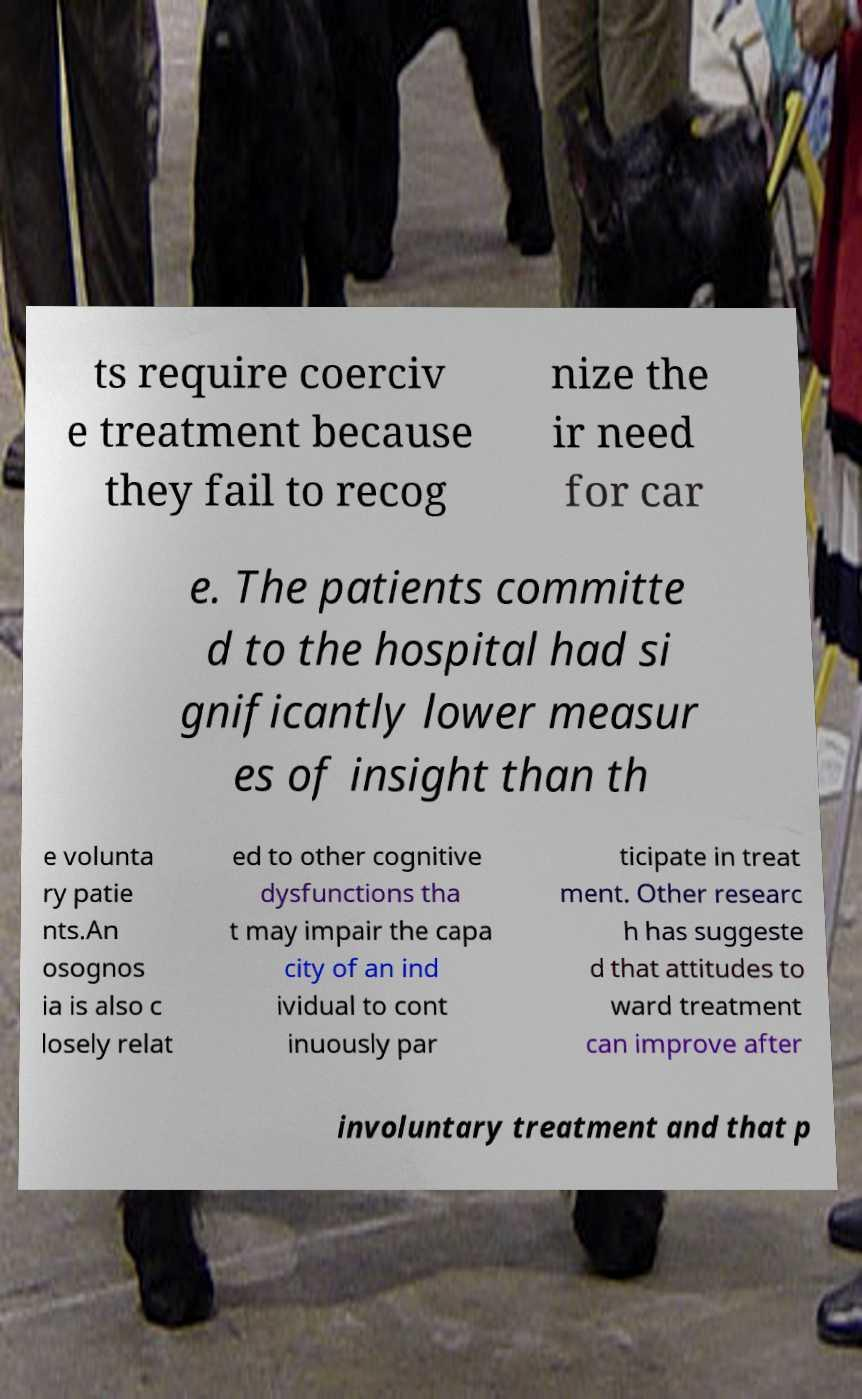Could you assist in decoding the text presented in this image and type it out clearly? ts require coerciv e treatment because they fail to recog nize the ir need for car e. The patients committe d to the hospital had si gnificantly lower measur es of insight than th e volunta ry patie nts.An osognos ia is also c losely relat ed to other cognitive dysfunctions tha t may impair the capa city of an ind ividual to cont inuously par ticipate in treat ment. Other researc h has suggeste d that attitudes to ward treatment can improve after involuntary treatment and that p 